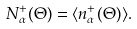<formula> <loc_0><loc_0><loc_500><loc_500>N _ { \alpha } ^ { + } ( \Theta ) = \langle n _ { \alpha } ^ { + } ( \Theta ) \rangle .</formula> 